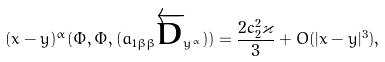<formula> <loc_0><loc_0><loc_500><loc_500>( x - y ) ^ { \alpha } ( \Phi , \Phi , ( a _ { 1 \beta \beta } \overleftarrow { D } _ { y ^ { \alpha } } ) ) = \frac { 2 c _ { 2 } ^ { 2 } \varkappa } { 3 } + O ( | x - y | ^ { 3 } ) ,</formula> 